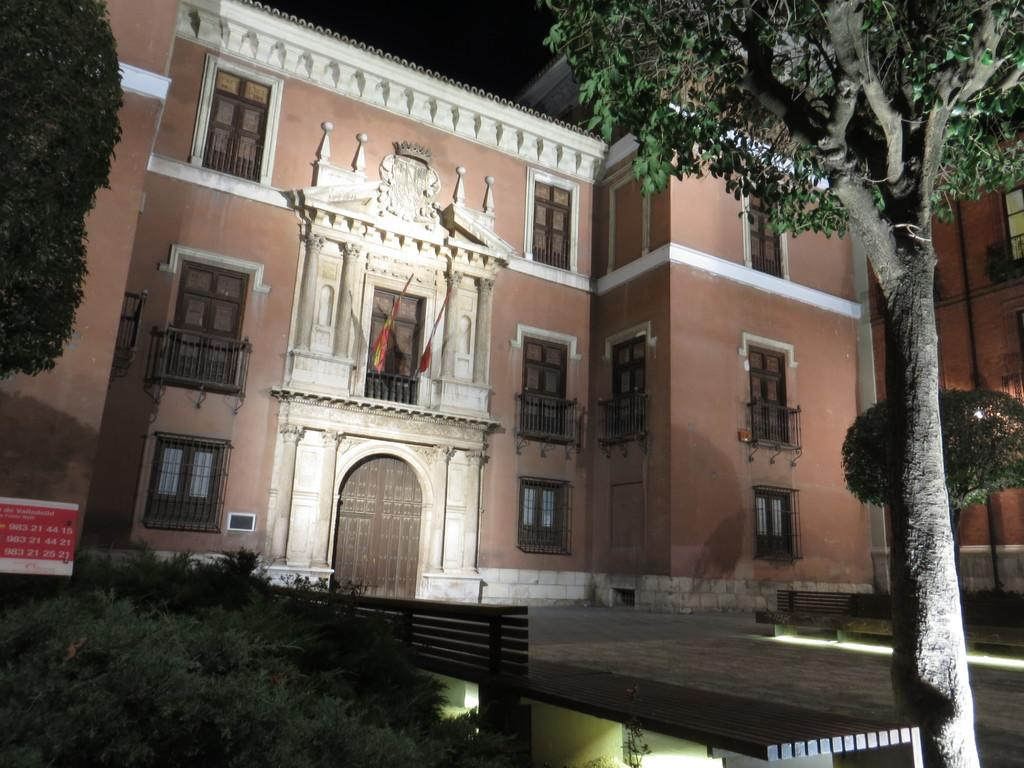What is the lighting condition in the image? The image was taken in the dark. What structure is visible in the image? There is a building in the image. What feature can be seen on the building? The building has windows. What type of vegetation is present in the image? There are trees in the image. What type of bone can be seen hanging from the trees in the image? There is no bone present in the image; it features a building with windows and trees. Is there a bomb visible in the image? No, there is no bomb present in the image. 